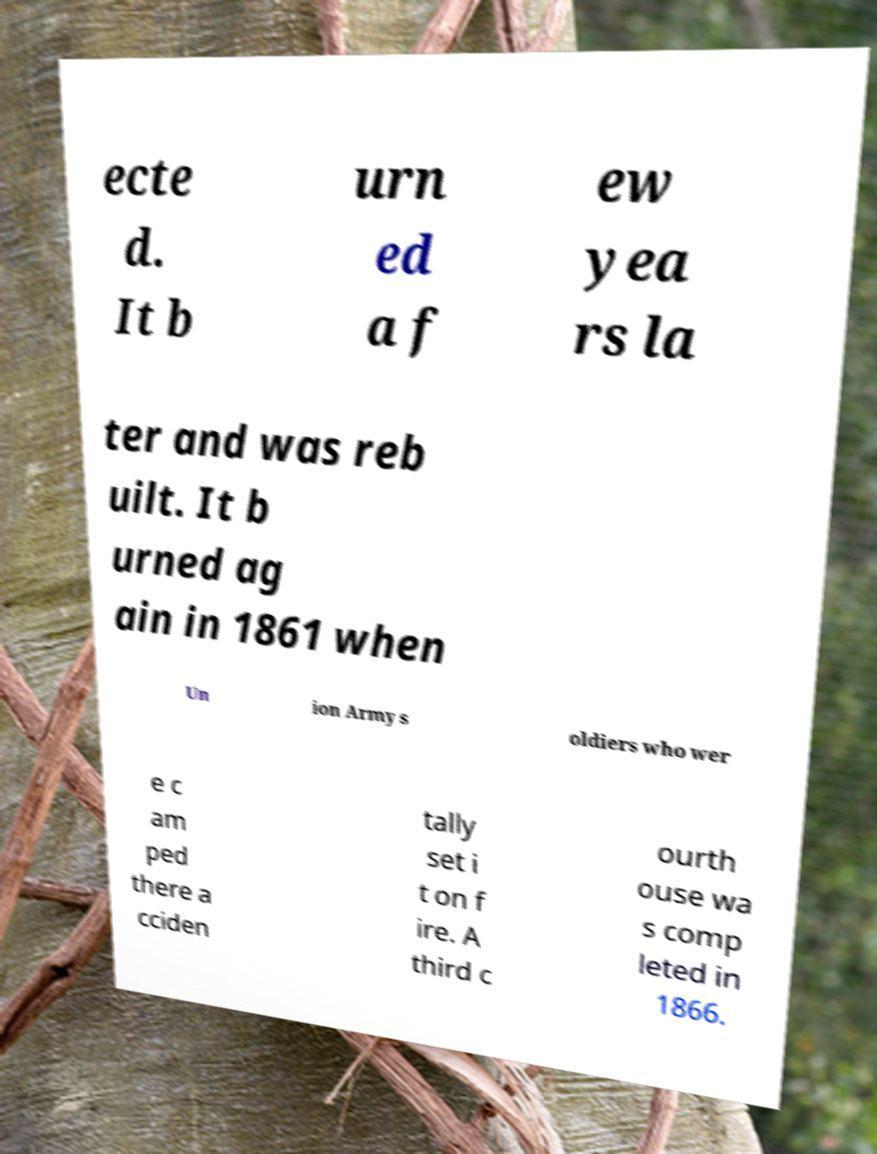Please read and relay the text visible in this image. What does it say? ecte d. It b urn ed a f ew yea rs la ter and was reb uilt. It b urned ag ain in 1861 when Un ion Army s oldiers who wer e c am ped there a cciden tally set i t on f ire. A third c ourth ouse wa s comp leted in 1866. 